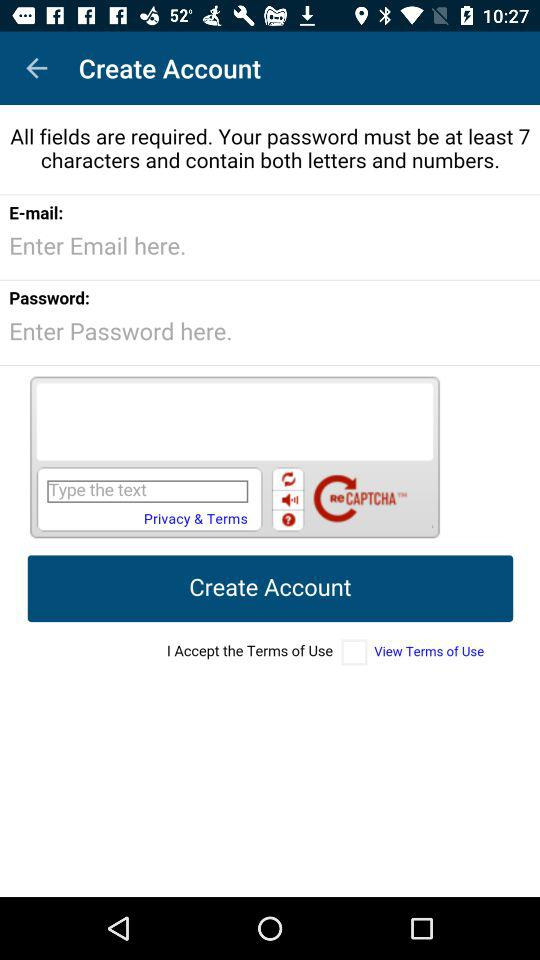How many fields are required for this form?
Answer the question using a single word or phrase. 3 